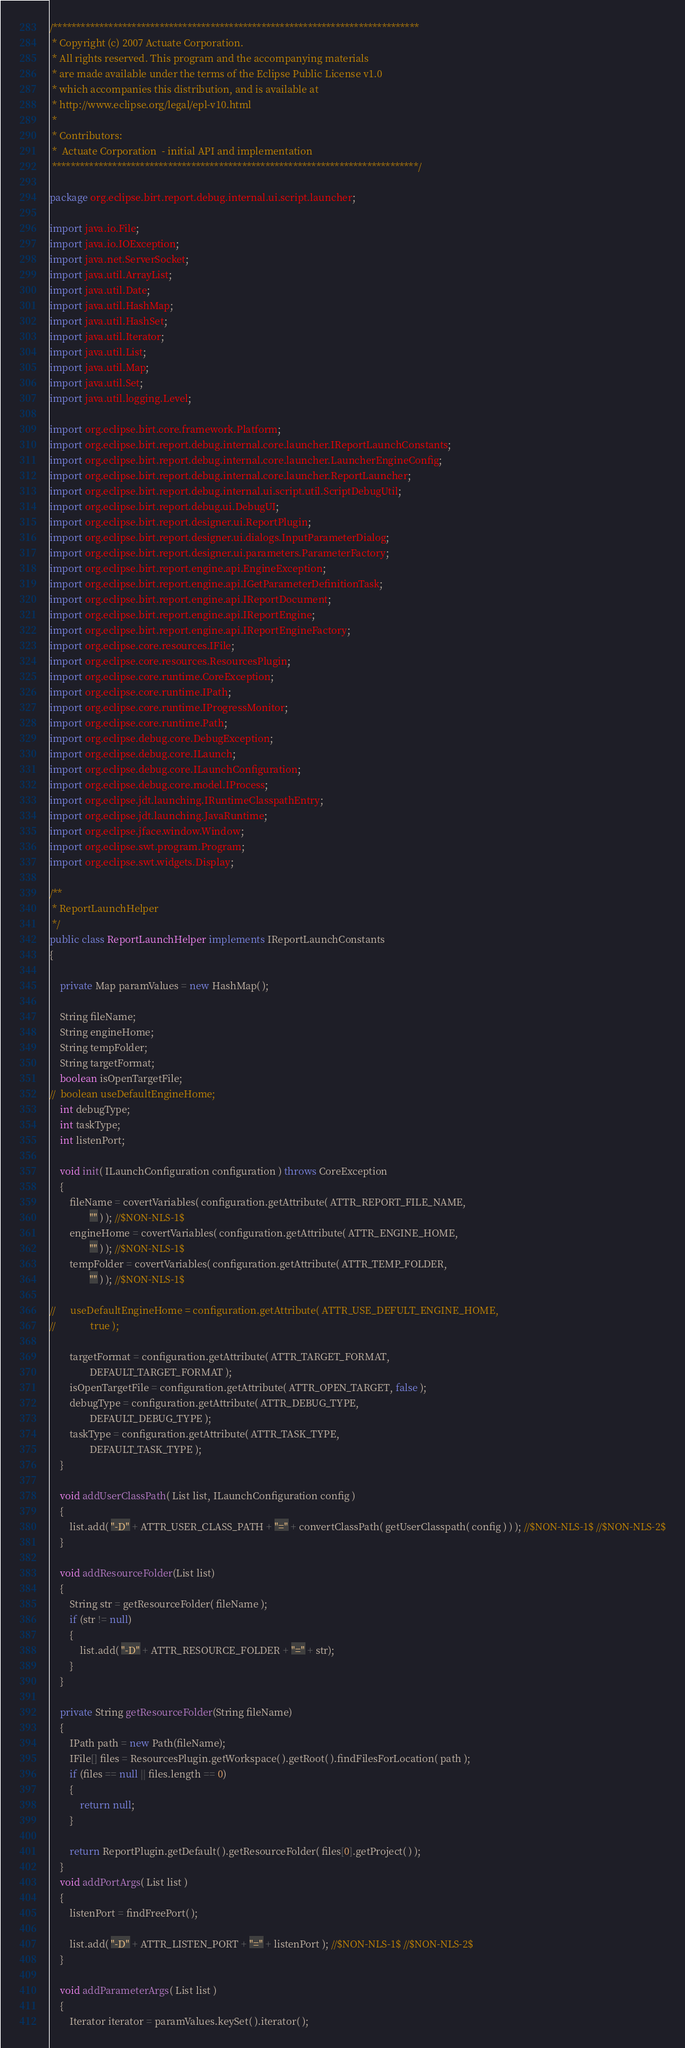Convert code to text. <code><loc_0><loc_0><loc_500><loc_500><_Java_>/*******************************************************************************
 * Copyright (c) 2007 Actuate Corporation.
 * All rights reserved. This program and the accompanying materials
 * are made available under the terms of the Eclipse Public License v1.0
 * which accompanies this distribution, and is available at
 * http://www.eclipse.org/legal/epl-v10.html
 *
 * Contributors:
 *  Actuate Corporation  - initial API and implementation
 *******************************************************************************/

package org.eclipse.birt.report.debug.internal.ui.script.launcher;

import java.io.File;
import java.io.IOException;
import java.net.ServerSocket;
import java.util.ArrayList;
import java.util.Date;
import java.util.HashMap;
import java.util.HashSet;
import java.util.Iterator;
import java.util.List;
import java.util.Map;
import java.util.Set;
import java.util.logging.Level;

import org.eclipse.birt.core.framework.Platform;
import org.eclipse.birt.report.debug.internal.core.launcher.IReportLaunchConstants;
import org.eclipse.birt.report.debug.internal.core.launcher.LauncherEngineConfig;
import org.eclipse.birt.report.debug.internal.core.launcher.ReportLauncher;
import org.eclipse.birt.report.debug.internal.ui.script.util.ScriptDebugUtil;
import org.eclipse.birt.report.debug.ui.DebugUI;
import org.eclipse.birt.report.designer.ui.ReportPlugin;
import org.eclipse.birt.report.designer.ui.dialogs.InputParameterDialog;
import org.eclipse.birt.report.designer.ui.parameters.ParameterFactory;
import org.eclipse.birt.report.engine.api.EngineException;
import org.eclipse.birt.report.engine.api.IGetParameterDefinitionTask;
import org.eclipse.birt.report.engine.api.IReportDocument;
import org.eclipse.birt.report.engine.api.IReportEngine;
import org.eclipse.birt.report.engine.api.IReportEngineFactory;
import org.eclipse.core.resources.IFile;
import org.eclipse.core.resources.ResourcesPlugin;
import org.eclipse.core.runtime.CoreException;
import org.eclipse.core.runtime.IPath;
import org.eclipse.core.runtime.IProgressMonitor;
import org.eclipse.core.runtime.Path;
import org.eclipse.debug.core.DebugException;
import org.eclipse.debug.core.ILaunch;
import org.eclipse.debug.core.ILaunchConfiguration;
import org.eclipse.debug.core.model.IProcess;
import org.eclipse.jdt.launching.IRuntimeClasspathEntry;
import org.eclipse.jdt.launching.JavaRuntime;
import org.eclipse.jface.window.Window;
import org.eclipse.swt.program.Program;
import org.eclipse.swt.widgets.Display;

/**
 * ReportLaunchHelper
 */
public class ReportLaunchHelper implements IReportLaunchConstants
{

	private Map paramValues = new HashMap( );

	String fileName;
	String engineHome;
	String tempFolder;
	String targetFormat;
	boolean isOpenTargetFile;
//	boolean useDefaultEngineHome;
	int debugType;
	int taskType;
	int listenPort;

	void init( ILaunchConfiguration configuration ) throws CoreException
	{
		fileName = covertVariables( configuration.getAttribute( ATTR_REPORT_FILE_NAME,
				"" ) ); //$NON-NLS-1$
		engineHome = covertVariables( configuration.getAttribute( ATTR_ENGINE_HOME,
				"" ) ); //$NON-NLS-1$
		tempFolder = covertVariables( configuration.getAttribute( ATTR_TEMP_FOLDER,
				"" ) ); //$NON-NLS-1$

//		useDefaultEngineHome = configuration.getAttribute( ATTR_USE_DEFULT_ENGINE_HOME,
//				true );

		targetFormat = configuration.getAttribute( ATTR_TARGET_FORMAT,
				DEFAULT_TARGET_FORMAT );
		isOpenTargetFile = configuration.getAttribute( ATTR_OPEN_TARGET, false );
		debugType = configuration.getAttribute( ATTR_DEBUG_TYPE,
				DEFAULT_DEBUG_TYPE );
		taskType = configuration.getAttribute( ATTR_TASK_TYPE,
				DEFAULT_TASK_TYPE );
	}

	void addUserClassPath( List list, ILaunchConfiguration config )
	{
		list.add( "-D" + ATTR_USER_CLASS_PATH + "=" + convertClassPath( getUserClasspath( config ) ) ); //$NON-NLS-1$ //$NON-NLS-2$
	}
	
	void addResourceFolder(List list)
	{
		String str = getResourceFolder( fileName );
		if (str != null)
		{
			list.add( "-D" + ATTR_RESOURCE_FOLDER + "=" + str);
		}
	}

	private String getResourceFolder(String fileName)
	{
		IPath path = new Path(fileName);
		IFile[] files = ResourcesPlugin.getWorkspace( ).getRoot( ).findFilesForLocation( path );
		if (files == null || files.length == 0)
		{
			return null;
		}
		
		return ReportPlugin.getDefault( ).getResourceFolder( files[0].getProject( ) );
	}
	void addPortArgs( List list )
	{
		listenPort = findFreePort( );

		list.add( "-D" + ATTR_LISTEN_PORT + "=" + listenPort ); //$NON-NLS-1$ //$NON-NLS-2$
	}

	void addParameterArgs( List list )
	{
		Iterator iterator = paramValues.keySet( ).iterator( );</code> 